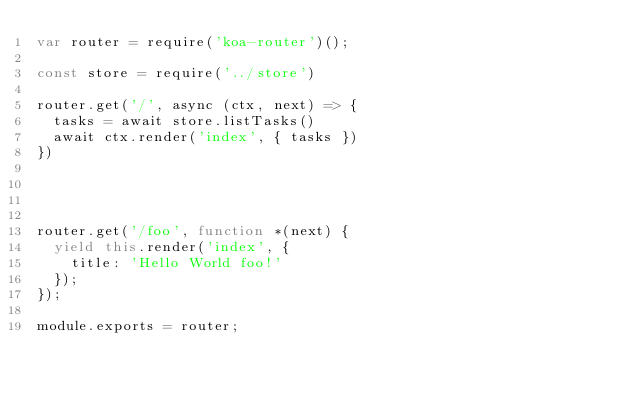Convert code to text. <code><loc_0><loc_0><loc_500><loc_500><_JavaScript_>var router = require('koa-router')();

const store = require('../store')

router.get('/', async (ctx, next) => {
  tasks = await store.listTasks()
  await ctx.render('index', { tasks })
})




router.get('/foo', function *(next) {
  yield this.render('index', {
    title: 'Hello World foo!'
  });
});

module.exports = router;
</code> 